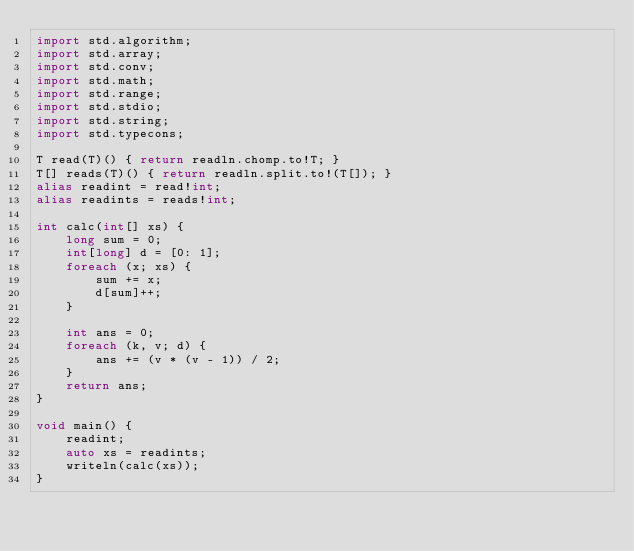Convert code to text. <code><loc_0><loc_0><loc_500><loc_500><_D_>import std.algorithm;
import std.array;
import std.conv;
import std.math;
import std.range;
import std.stdio;
import std.string;
import std.typecons;

T read(T)() { return readln.chomp.to!T; }
T[] reads(T)() { return readln.split.to!(T[]); }
alias readint = read!int;
alias readints = reads!int;

int calc(int[] xs) {
    long sum = 0;
    int[long] d = [0: 1];
    foreach (x; xs) {
        sum += x;
        d[sum]++;
    }

    int ans = 0;
    foreach (k, v; d) {
        ans += (v * (v - 1)) / 2;
    }
    return ans;
}

void main() {
    readint;
    auto xs = readints;
    writeln(calc(xs));
}
</code> 